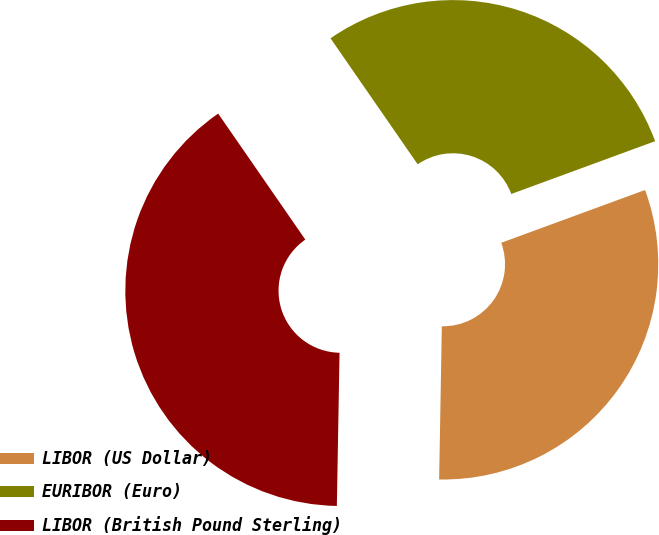Convert chart. <chart><loc_0><loc_0><loc_500><loc_500><pie_chart><fcel>LIBOR (US Dollar)<fcel>EURIBOR (Euro)<fcel>LIBOR (British Pound Sterling)<nl><fcel>30.88%<fcel>29.03%<fcel>40.09%<nl></chart> 